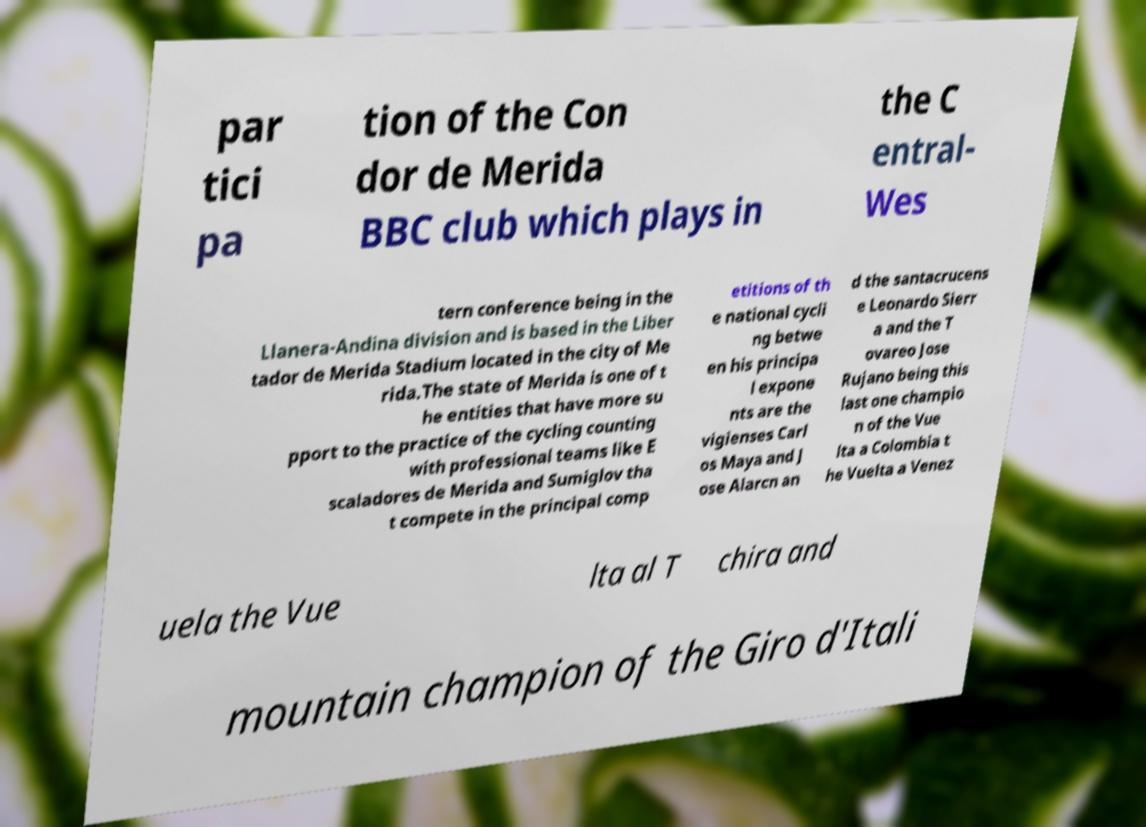What messages or text are displayed in this image? I need them in a readable, typed format. par tici pa tion of the Con dor de Merida BBC club which plays in the C entral- Wes tern conference being in the Llanera-Andina division and is based in the Liber tador de Merida Stadium located in the city of Me rida.The state of Merida is one of t he entities that have more su pport to the practice of the cycling counting with professional teams like E scaladores de Merida and Sumiglov tha t compete in the principal comp etitions of th e national cycli ng betwe en his principa l expone nts are the vigienses Carl os Maya and J ose Alarcn an d the santacrucens e Leonardo Sierr a and the T ovareo Jose Rujano being this last one champio n of the Vue lta a Colombia t he Vuelta a Venez uela the Vue lta al T chira and mountain champion of the Giro d'Itali 